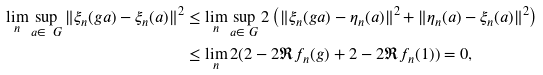<formula> <loc_0><loc_0><loc_500><loc_500>\lim _ { n } \sup _ { a \in \ G } \| \xi _ { n } ( g a ) - \xi _ { n } ( a ) \| ^ { 2 } & \leq \lim _ { n } \sup _ { a \in \ G } 2 \left ( \| \xi _ { n } ( g a ) - \eta _ { n } ( a ) \| ^ { 2 } + \| \eta _ { n } ( a ) - \xi _ { n } ( a ) \| ^ { 2 } \right ) \\ & \leq \lim _ { n } 2 ( 2 - 2 \Re f _ { n } ( g ) + 2 - 2 \Re f _ { n } ( 1 ) ) = 0 ,</formula> 